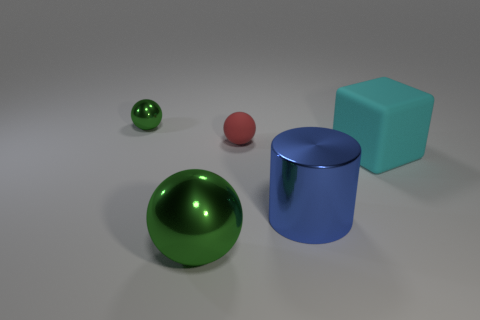Do the metal ball behind the big rubber block and the tiny matte object have the same color?
Your answer should be compact. No. How many other objects are there of the same size as the cylinder?
Offer a terse response. 2. Are the large green object and the cyan thing made of the same material?
Your answer should be compact. No. What is the color of the small object right of the green sphere left of the big green metallic sphere?
Offer a terse response. Red. There is a matte thing that is the same shape as the large green shiny object; what size is it?
Keep it short and to the point. Small. Do the tiny metallic object and the matte cube have the same color?
Your answer should be very brief. No. There is a green object that is to the right of the metallic sphere behind the large blue metal thing; what number of cylinders are on the right side of it?
Provide a short and direct response. 1. Are there more yellow matte cubes than metallic cylinders?
Offer a very short reply. No. What number of large gray metallic cylinders are there?
Offer a very short reply. 0. What shape is the green shiny thing that is behind the green shiny sphere right of the green metal object behind the large green metal object?
Provide a succinct answer. Sphere. 